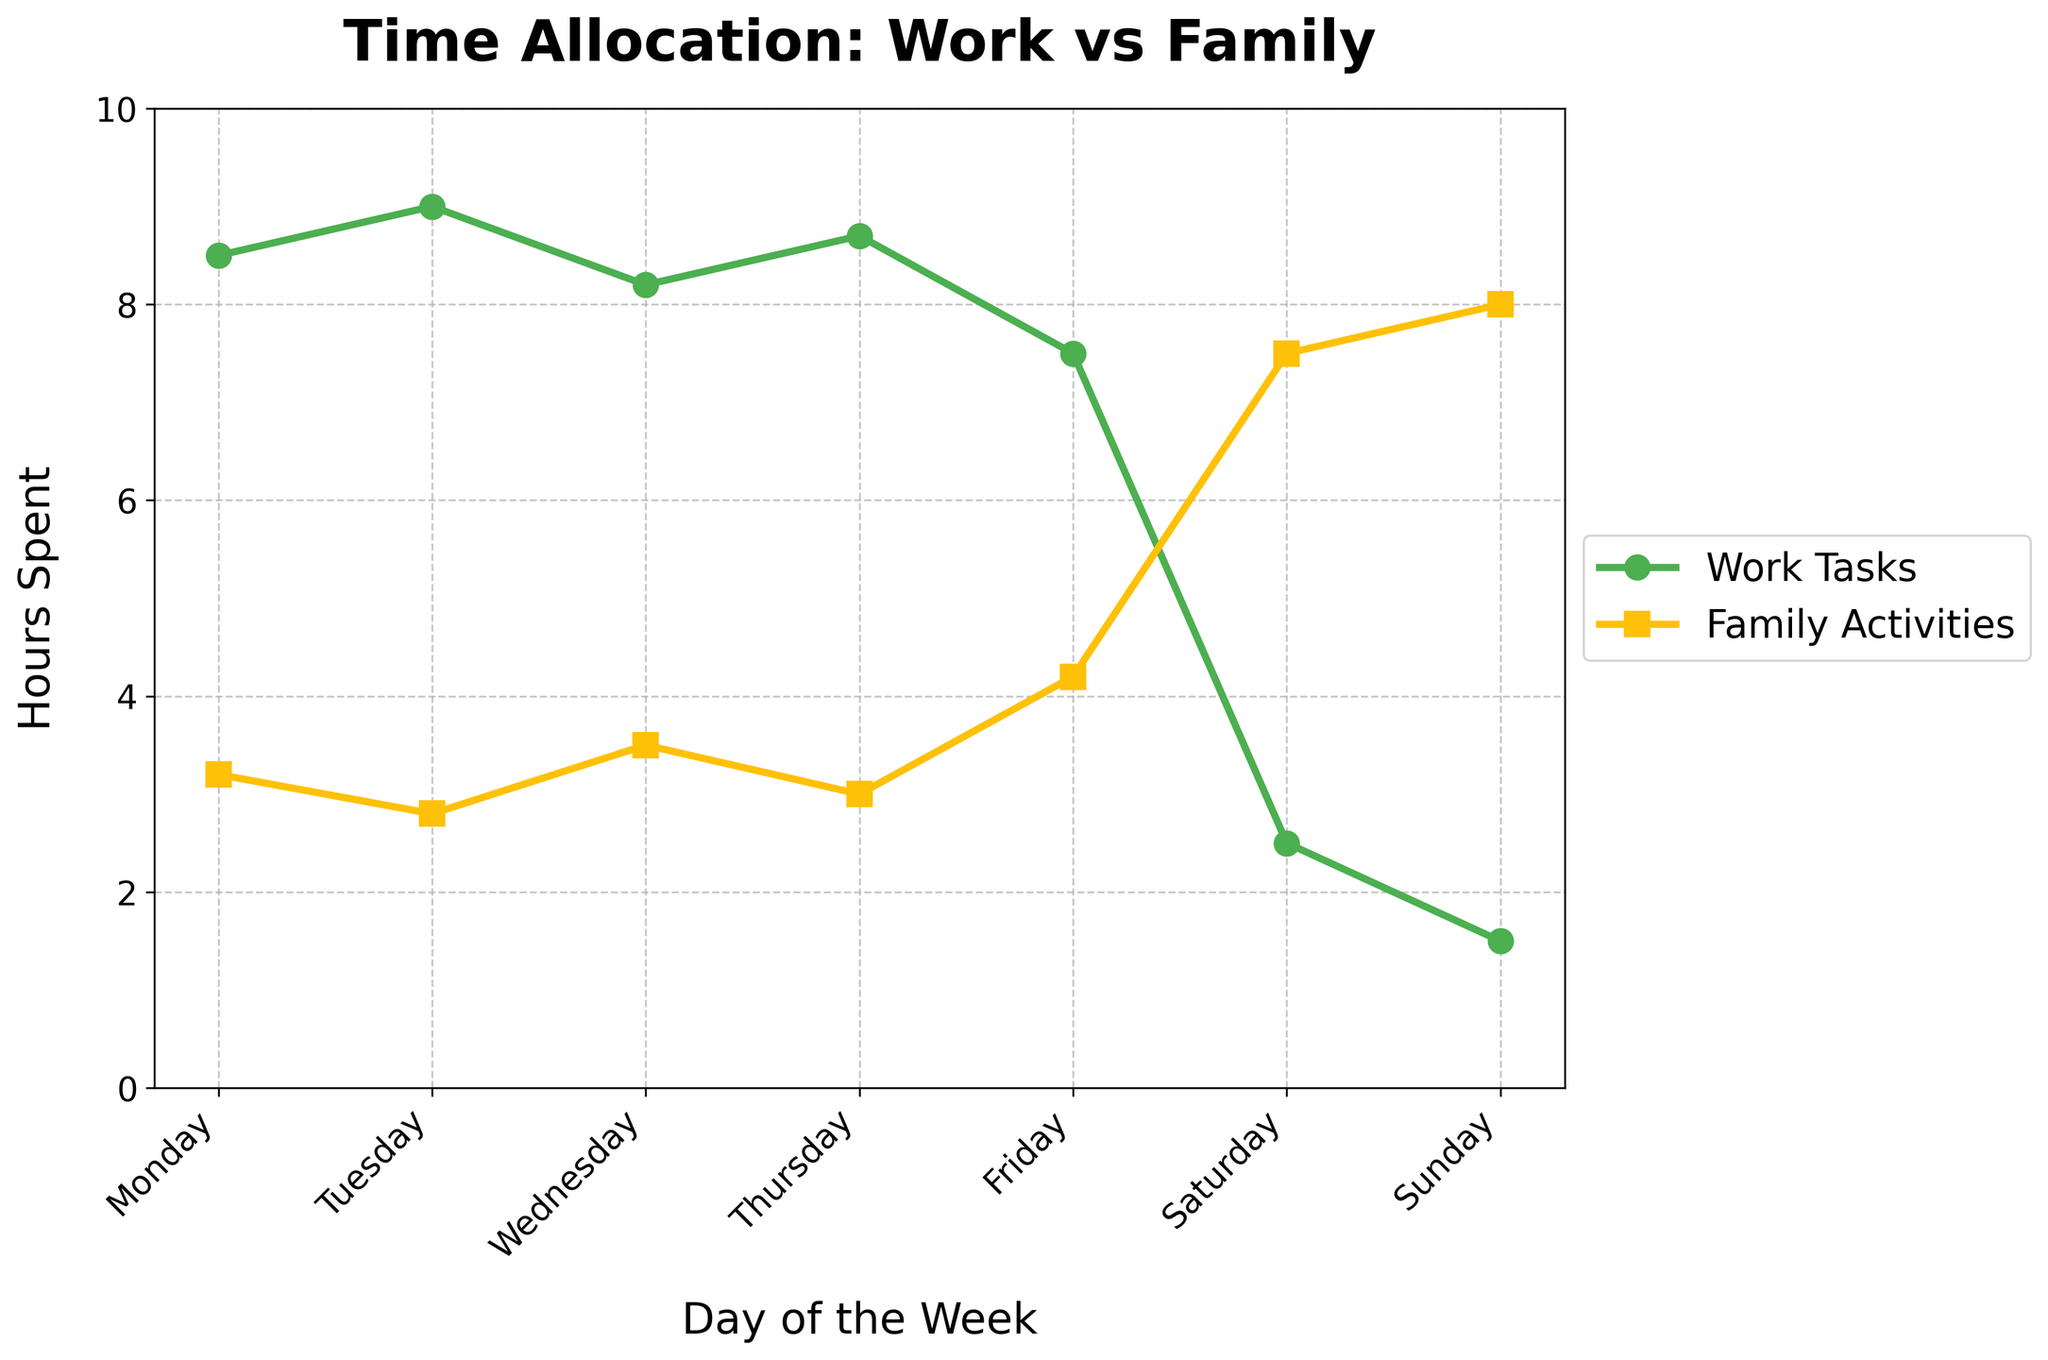How many more hours are spent on family activities compared to work tasks on Saturday? To find this, subtract the hours spent on work tasks from the hours spent on family activities on Saturday. This is 7.5 (family activities) - 2.5 (work tasks).
Answer: 5 hours On which day is the time spent on work tasks the highest? By looking at the line for work tasks, the highest point is on Tuesday with 9 hours.
Answer: Tuesday Compare the time spent on family activities from Monday to Wednesday. How much does it increase? Calculate the difference between the family activities on Wednesday and Monday. This is 3.5 - 3.2.
Answer: 0.3 hours What is the average amount of time spent on family activities during the weekend (Saturday and Sunday)? Add the family activities hours for Saturday and Sunday and then divide by 2. This is (7.5 + 8.0) / 2.
Answer: 7.75 hours On which day is the balance between work tasks and family activities the closest? Identify the day where the difference between work tasks and family activities is smallest. Thursday has 8.7 hours on work tasks and 3.0 on family activities, so the difference is 5.7 hours, which is the smallest among all days.
Answer: Thursday On Sunday, how much more time is spent on family activities compared to work tasks? Subtract the hours spent on work tasks from the hours spent on family activities on Sunday. This is 8.0 - 1.5.
Answer: 6.5 hours Which day has the lowest amount of time spent on work tasks and what is the amount? By inspecting the graph, Sunday has the lowest amount of time spent on work tasks with 1.5 hours.
Answer: Sunday, 1.5 hours How does the time spent on work tasks change from Monday to Friday? Observe the work tasks line from Monday to Friday. It decreases overall from 8.5 hours on Monday to 7.5 hours on Friday.
Answer: Decrease What is the total time spent on family activities from Monday to Friday? Sum the family activities hours from Monday to Friday: 3.2 + 2.8 + 3.5 + 3.0 + 4.2. This equals 16.7 hours.
Answer: 16.7 hours Which day shows the largest absolute difference between time spent on work tasks and family activities? Calculate the absolute differences for each day and identify the largest. Sunday has the largest difference:
Answer: 6.5 hours 